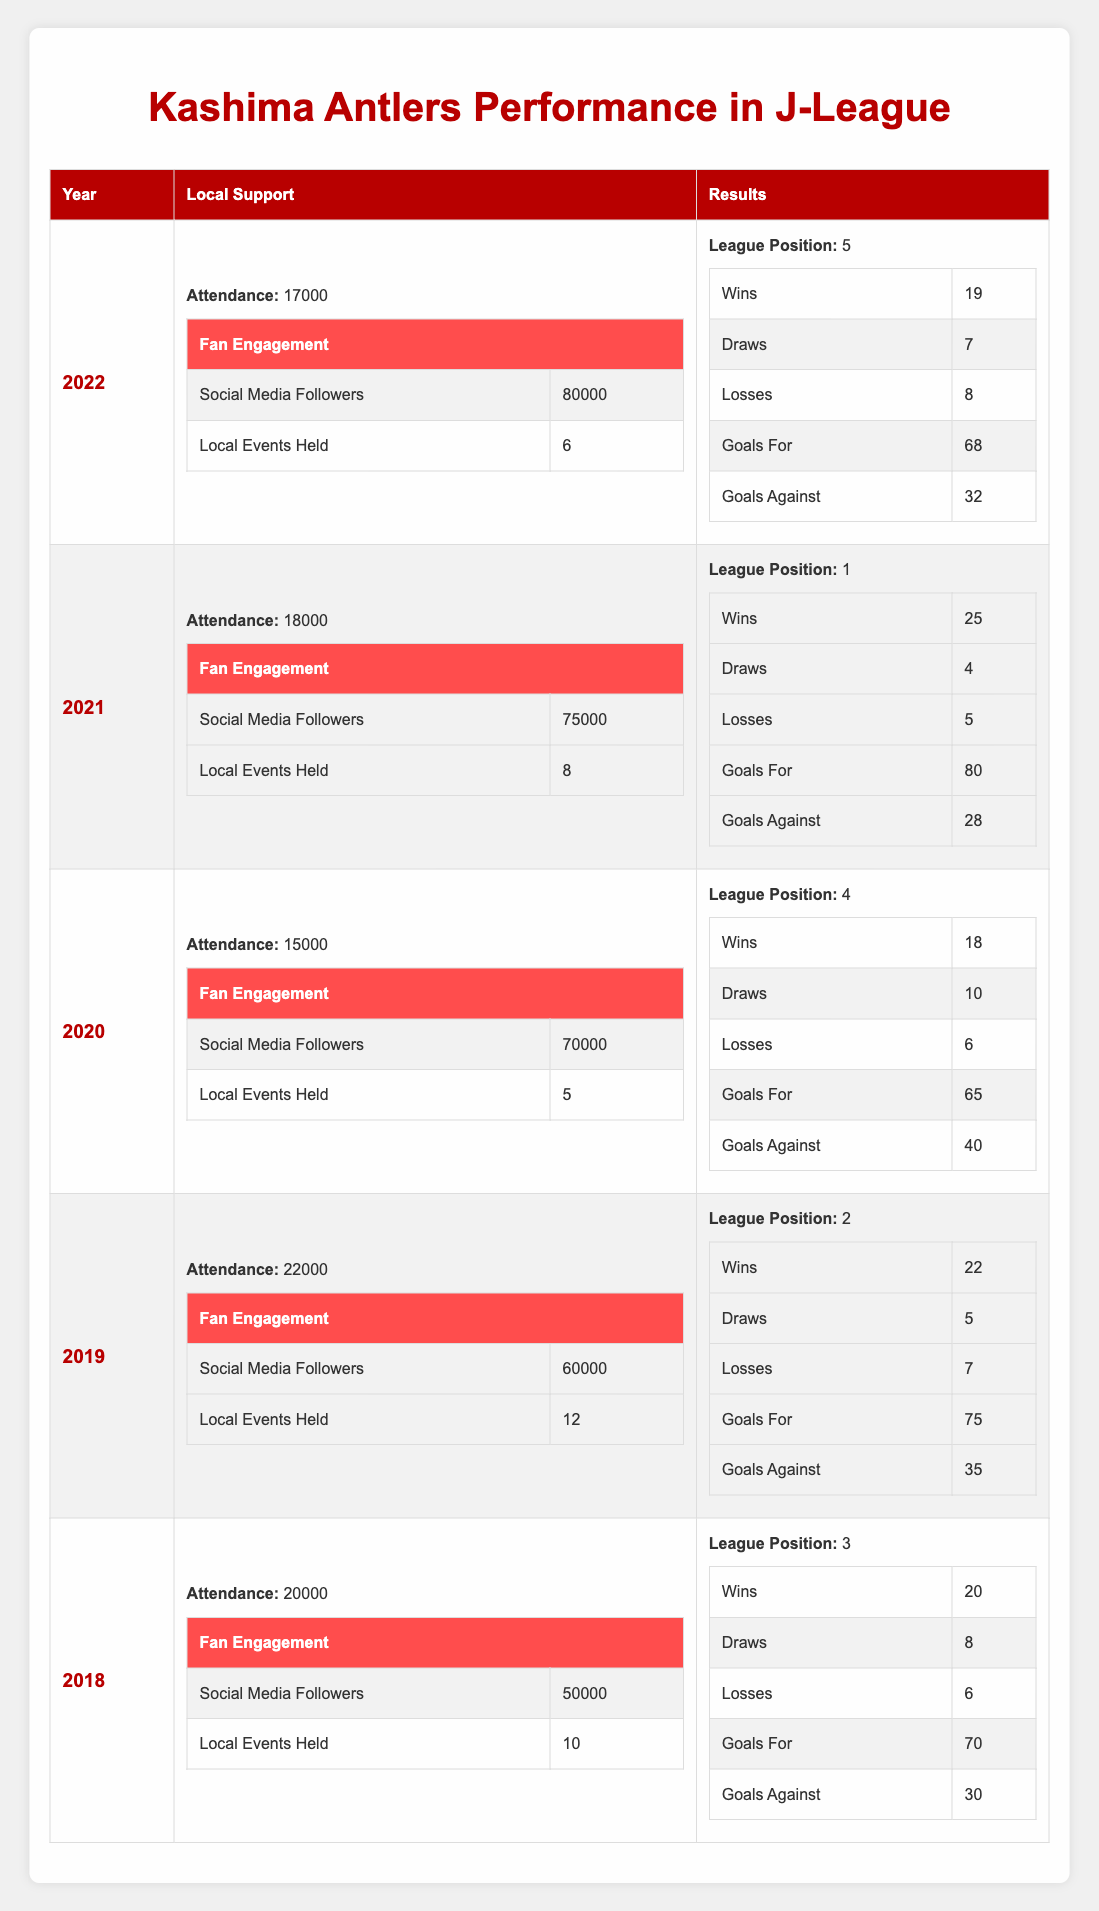What was the League Position of Kashima Antlers in 2021? The League Position for Kashima Antlers in 2021 is stated directly in the table as "1".
Answer: 1 What was the attendance in 2019? The table shows that the attendance in 2019 was "22000".
Answer: 22000 How many Local Events were held in 2020? According to the table, the number of Local Events held in 2020 is "5".
Answer: 5 What is the total number of Wins across all seasons? To find the total Wins, we add the Wins from all years: 20 (2018) + 22 (2019) + 18 (2020) + 25 (2021) + 19 (2022) = 104.
Answer: 104 Did the attendance in 2022 increase compared to 2020? The attendance in 2022 (17000) is greater than in 2020 (15000), making the statement true.
Answer: Yes What was the average number of Goals For over the five seasons? The Goals For are: 70 (2018), 75 (2019), 65 (2020), 80 (2021), 68 (2022). The total is 70 + 75 + 65 + 80 + 68 = 358. The average is 358/5 = 71.6.
Answer: 71.6 In which year did Kashima Antlers have the highest attendance? The attendance figures show that 2019 had the highest attendance at "22000".
Answer: 2019 What is the difference in League Position between 2019 and 2022? The League Position for 2019 is "2" and for 2022 it is "5". The difference is 5 - 2 = 3.
Answer: 3 Was the number of Wins in 2021 greater than the number of Goals Against in the same year? In 2021, the Wins were "25" and the Goals Against were "28". Since 25 is less than 28, the statement is false.
Answer: No What season had the lowest number of Local Events held? According to the data, the lowest number of Local Events is "5" in 2020.
Answer: 2020 